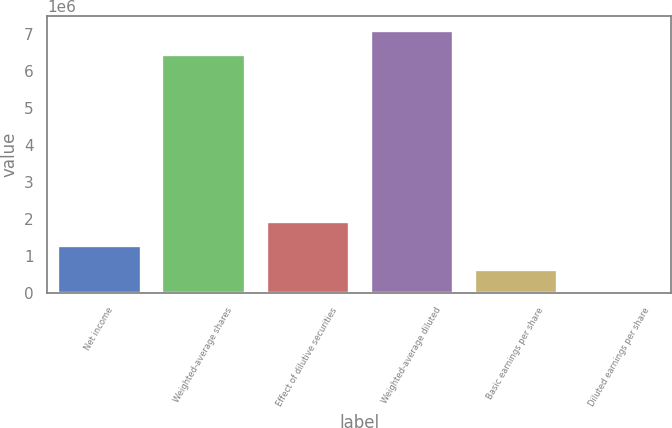Convert chart. <chart><loc_0><loc_0><loc_500><loc_500><bar_chart><fcel>Net income<fcel>Weighted-average shares<fcel>Effect of dilutive securities<fcel>Weighted-average diluted<fcel>Basic earnings per share<fcel>Diluted earnings per share<nl><fcel>1.30433e+06<fcel>6.47732e+06<fcel>1.95649e+06<fcel>7.12948e+06<fcel>652169<fcel>5.68<nl></chart> 